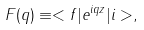<formula> <loc_0><loc_0><loc_500><loc_500>F ( q ) \equiv < f | e ^ { i q z } | i > ,</formula> 